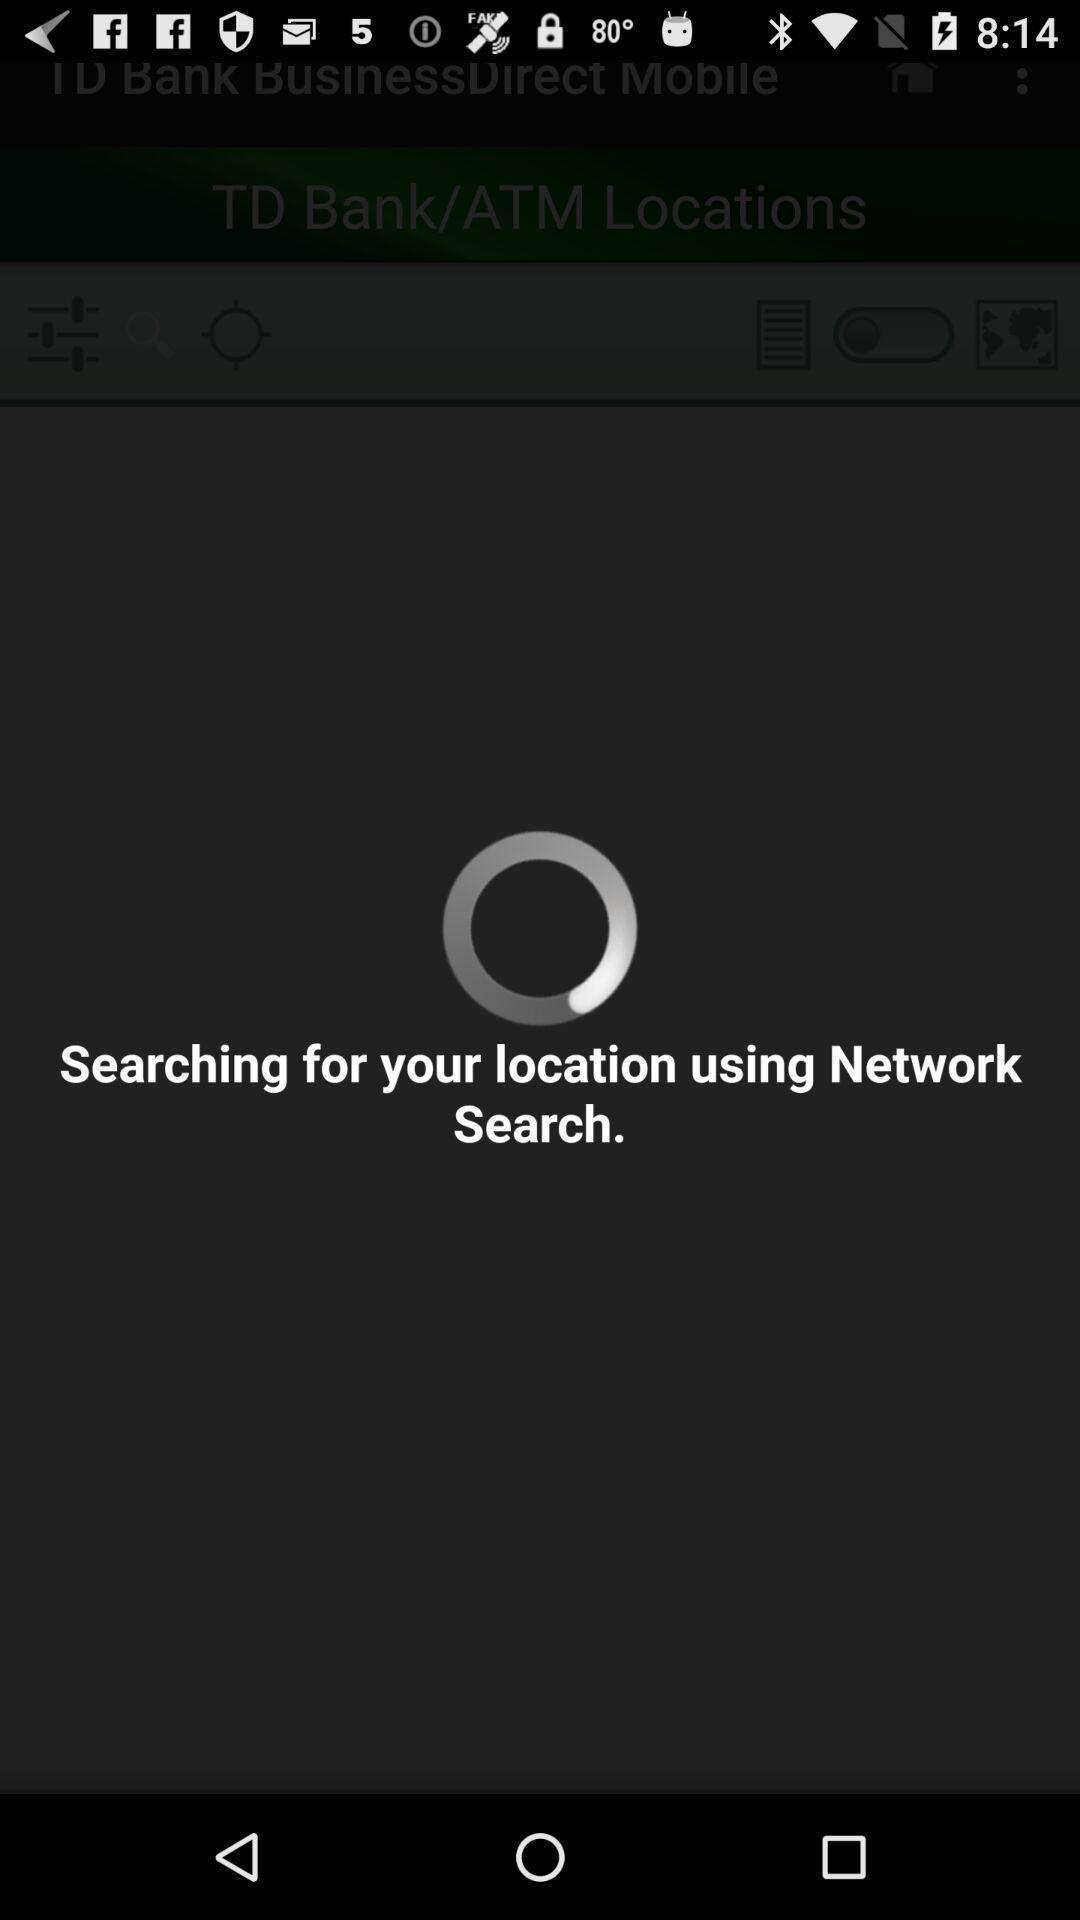Summarize the information in this screenshot. Pop up displaying reload icon with a text. 